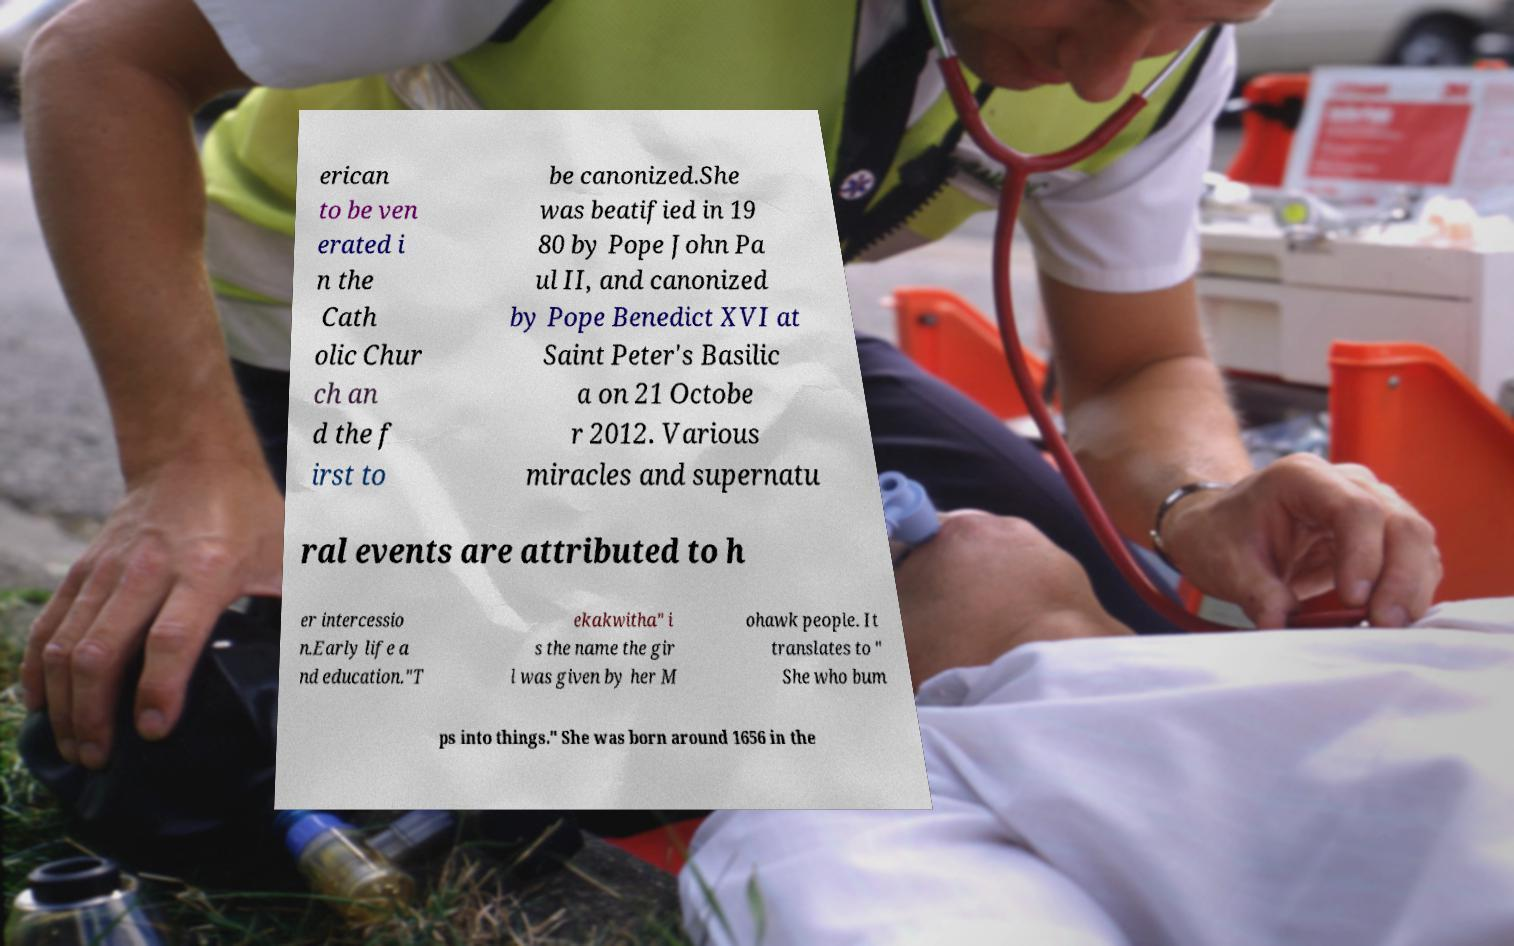I need the written content from this picture converted into text. Can you do that? erican to be ven erated i n the Cath olic Chur ch an d the f irst to be canonized.She was beatified in 19 80 by Pope John Pa ul II, and canonized by Pope Benedict XVI at Saint Peter's Basilic a on 21 Octobe r 2012. Various miracles and supernatu ral events are attributed to h er intercessio n.Early life a nd education."T ekakwitha" i s the name the gir l was given by her M ohawk people. It translates to " She who bum ps into things." She was born around 1656 in the 